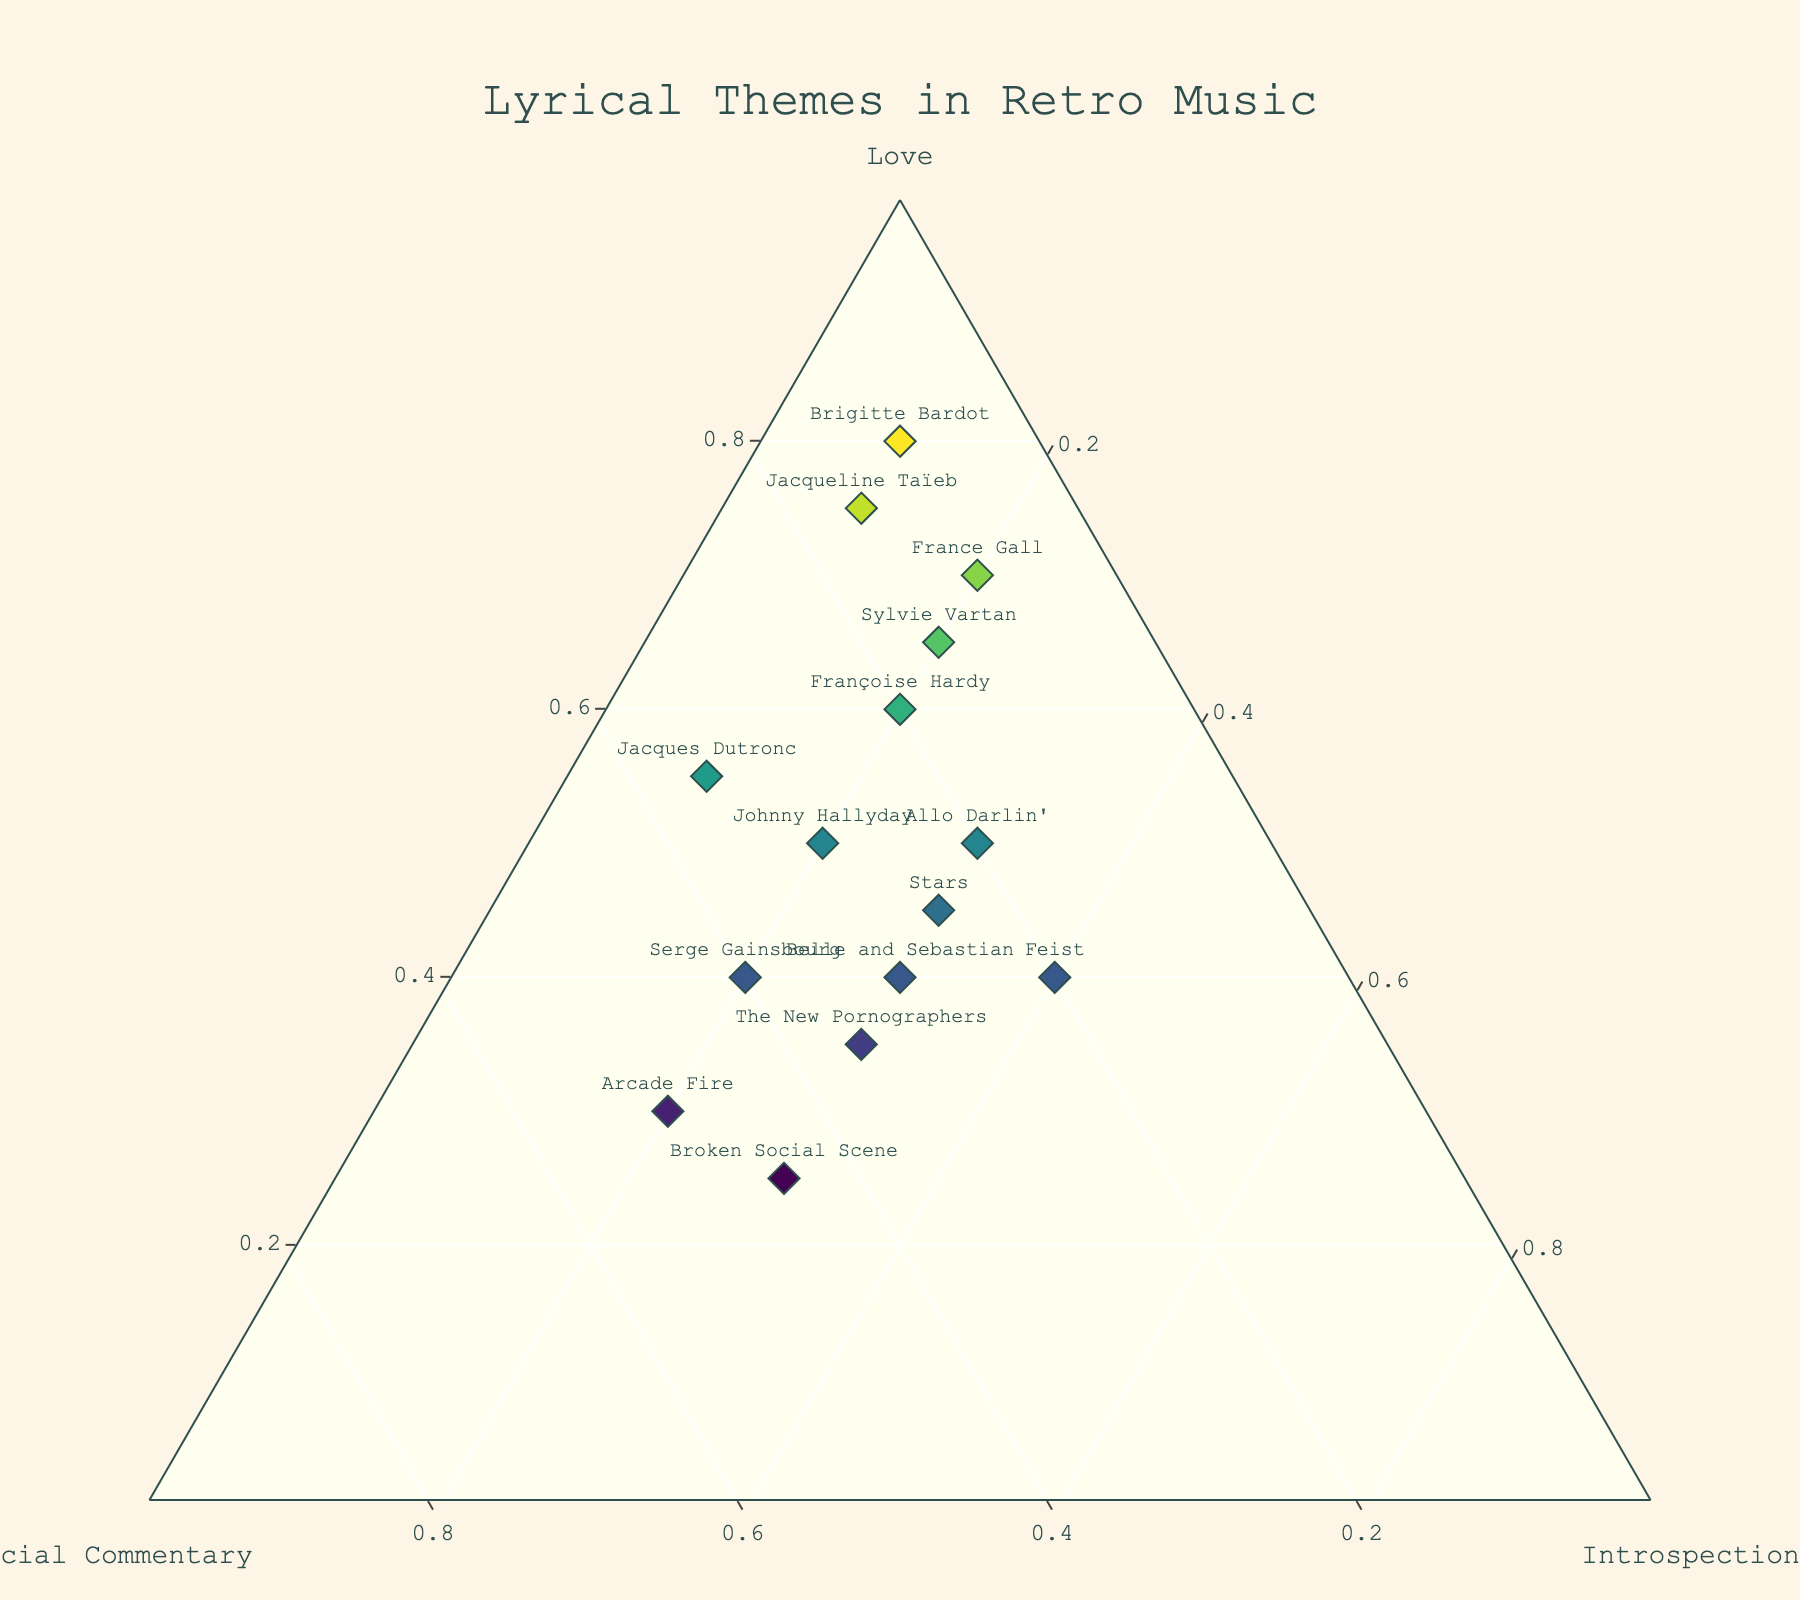who has the highest percentage of lyrics about love? To find the artist with the highest percentage of lyrics about love, look for the data point closest to the 'Love' axis. The data point that is most aligned with the 'Love' axis represents the highest percentage.
Answer: Brigitte Bardot How many artists have more than 50% of their lyrics about love? To answer this, count the number of data points that are positioned more than halfway along the 'Love' axis, which corresponds to more than 50%.
Answer: 5 Which artist balances love, social commentary, and introspection equally? A balanced lyrical distribution would be represented by a point closest to the center of the ternary plot (one-third distance from each axis). Check for points near this central area.
Answer: Belle and Sebastian What percentage of Feist’s lyrics are about introspection? Find Feist's data point on the plot and read off the value from the 'Introspection' axis. Feist is positioned along the respective axis lines indicating her percentages.
Answer: 40% Compare the lyrical themes of Serge Gainsbourg and Arcade Fire. Which has more focus on social commentary? Locate both artists on the plot and compare their distances along the 'Social Commentary' axis. Serge Gainsbourg's data point relative to the axis will show his theme percentage. Compare with Arcade Fire's position.
Answer: Arcade Fire Is there any artist with 20% lyrics for introspection across the board? Check the plot for data points that align with the 20% mark on the 'Introspection' axis. Multiple points may meet this criteria.
Answer: Yes What is the most common percentage range for introspection across artists? Analyze the distribution of the data points along the 'Introspection' axis. Determine the most frequent grouping or cluster edge percentage range.
Answer: 20-30% Which Canadian artist has a higher percentage of lyrics about love, Feist or Broken Social Scene? Locate Feist's and Broken Social Scene's positions relative to the 'Love' axis and compare.
Answer: Feist What’s the combined percentage of social commentary for Arcade Fire and The New Pornographers? Find both data points and add their values on the ‘Social Commentary’ axis. Arcade Fire has 50%, and The New Pornographers have 35%. Adding them up gives the combined percentage.
Answer: 85% Does Allo Darlin' have more social commentary or introspection in their lyrics? Check Allo Darlin's position on the plot and compare the 'Social Commentary' percentage with 'Introspection'.
Answer: Introspection 